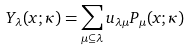Convert formula to latex. <formula><loc_0><loc_0><loc_500><loc_500>Y _ { \lambda } ( x ; \kappa ) = \sum _ { \mu \subseteq \lambda } u _ { \lambda \mu } P _ { \mu } ( x ; \kappa )</formula> 